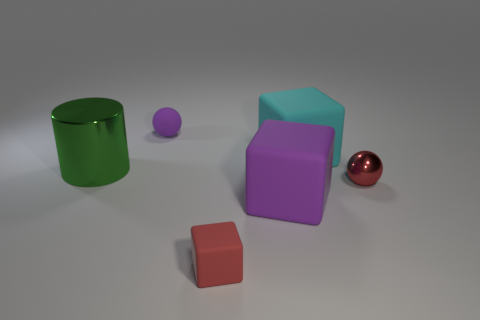Subtract 1 blocks. How many blocks are left? 2 Add 4 large green cylinders. How many objects exist? 10 Subtract all spheres. How many objects are left? 4 Add 3 brown shiny cubes. How many brown shiny cubes exist? 3 Subtract 1 purple cubes. How many objects are left? 5 Subtract all big blocks. Subtract all cyan shiny spheres. How many objects are left? 4 Add 2 tiny purple spheres. How many tiny purple spheres are left? 3 